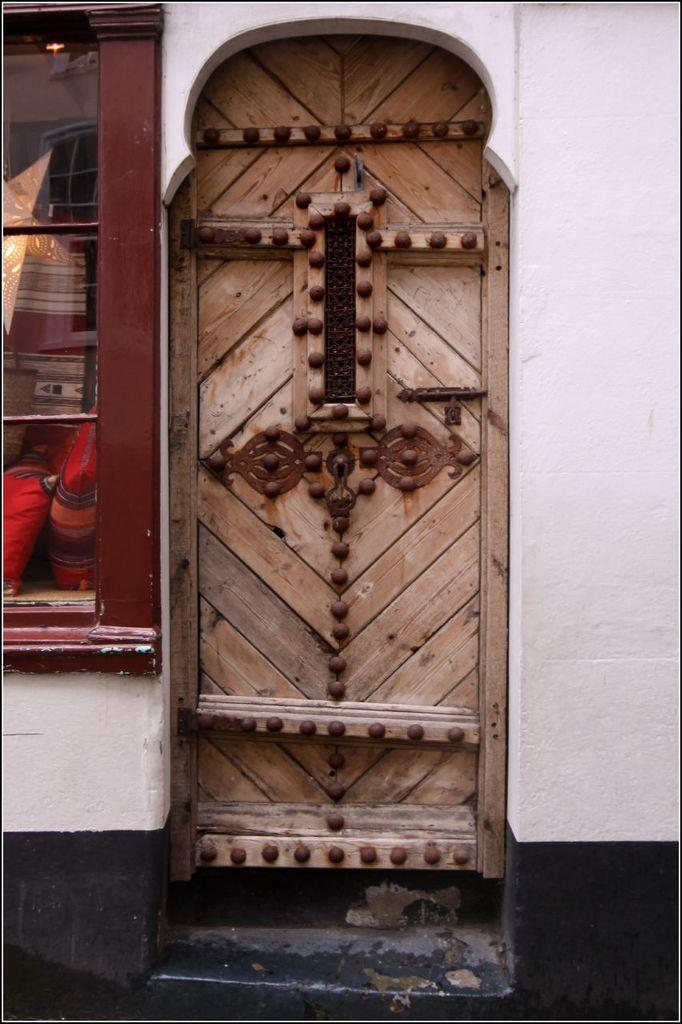What type of door is visible in the image? There is a wooden door in the image. What material is used for the window on the left side of the image? The window on the left side of the image is made of glass. What type of prose can be seen on the door in the image? There is no prose present on the door in the image; it is a wooden door. What color is the umbrella in the image? There is no umbrella present in the image. 